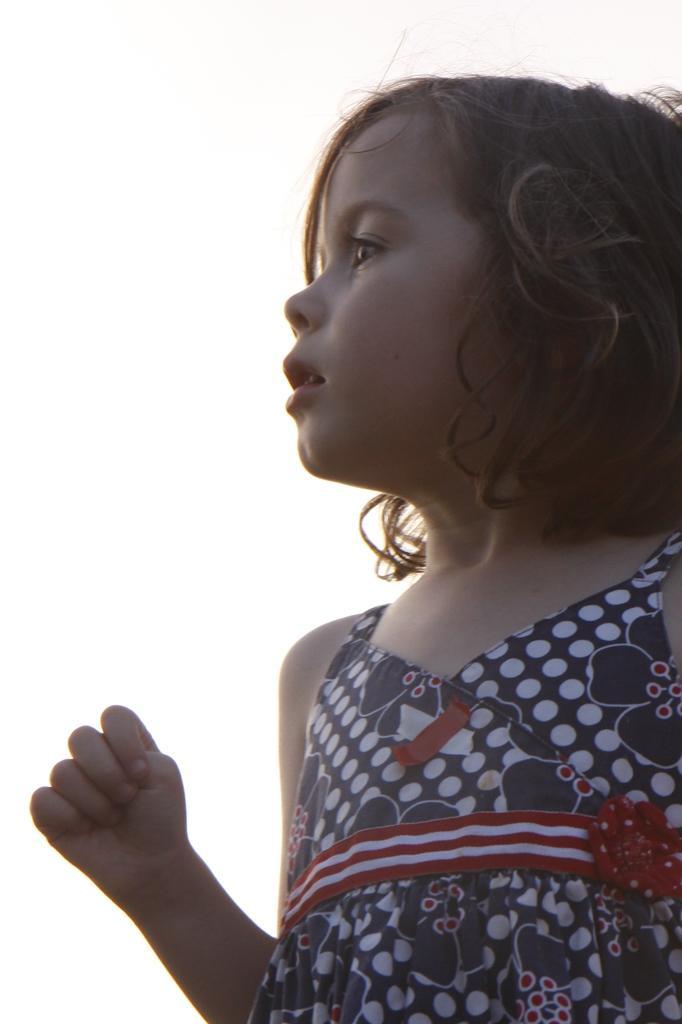Describe this image in one or two sentences. In this image there is a who is wearing the frock. 